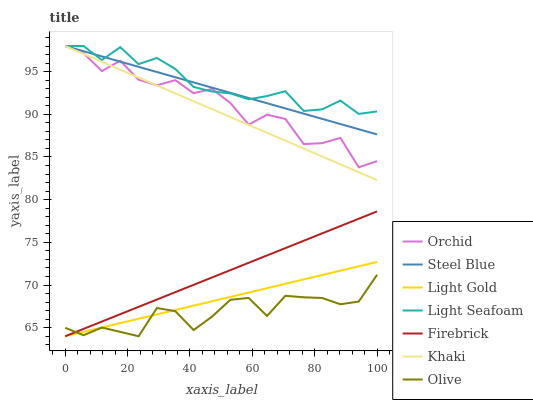Does Firebrick have the minimum area under the curve?
Answer yes or no. No. Does Firebrick have the maximum area under the curve?
Answer yes or no. No. Is Firebrick the smoothest?
Answer yes or no. No. Is Firebrick the roughest?
Answer yes or no. No. Does Steel Blue have the lowest value?
Answer yes or no. No. Does Firebrick have the highest value?
Answer yes or no. No. Is Firebrick less than Light Seafoam?
Answer yes or no. Yes. Is Orchid greater than Olive?
Answer yes or no. Yes. Does Firebrick intersect Light Seafoam?
Answer yes or no. No. 